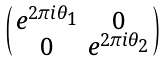<formula> <loc_0><loc_0><loc_500><loc_500>\begin{psmallmatrix} e ^ { 2 \pi i \theta _ { 1 } } & 0 \\ 0 & e ^ { 2 \pi i \theta _ { 2 } } \end{psmallmatrix}</formula> 